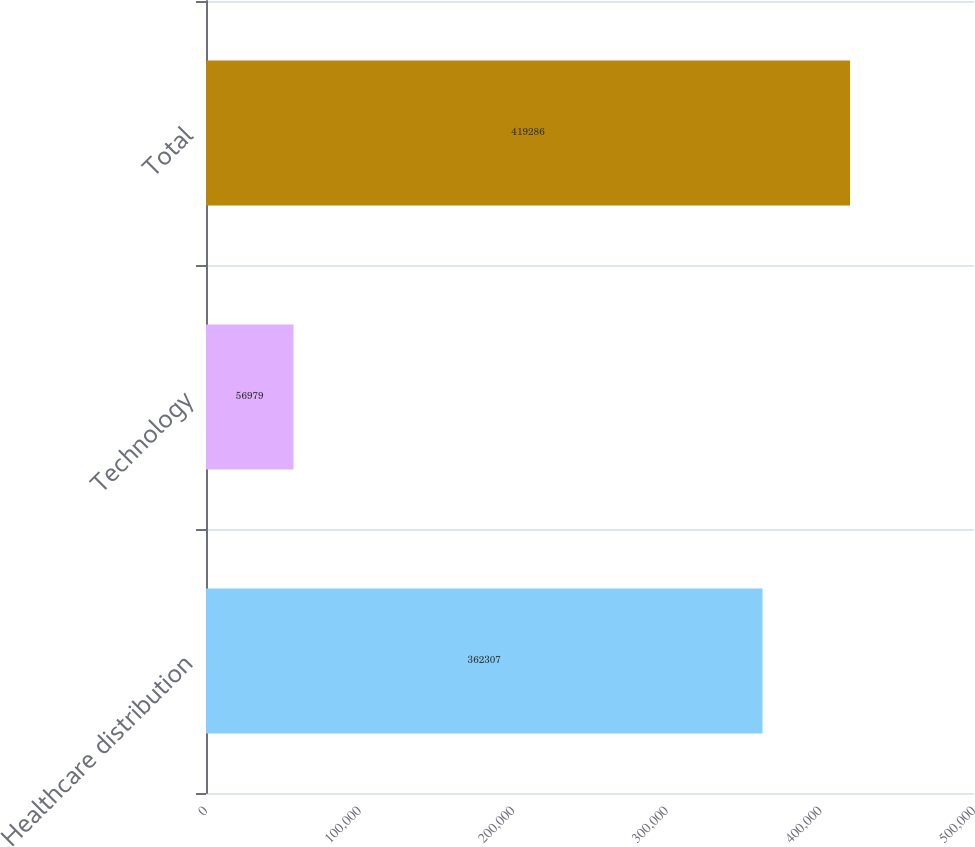Convert chart to OTSL. <chart><loc_0><loc_0><loc_500><loc_500><bar_chart><fcel>Healthcare distribution<fcel>Technology<fcel>Total<nl><fcel>362307<fcel>56979<fcel>419286<nl></chart> 